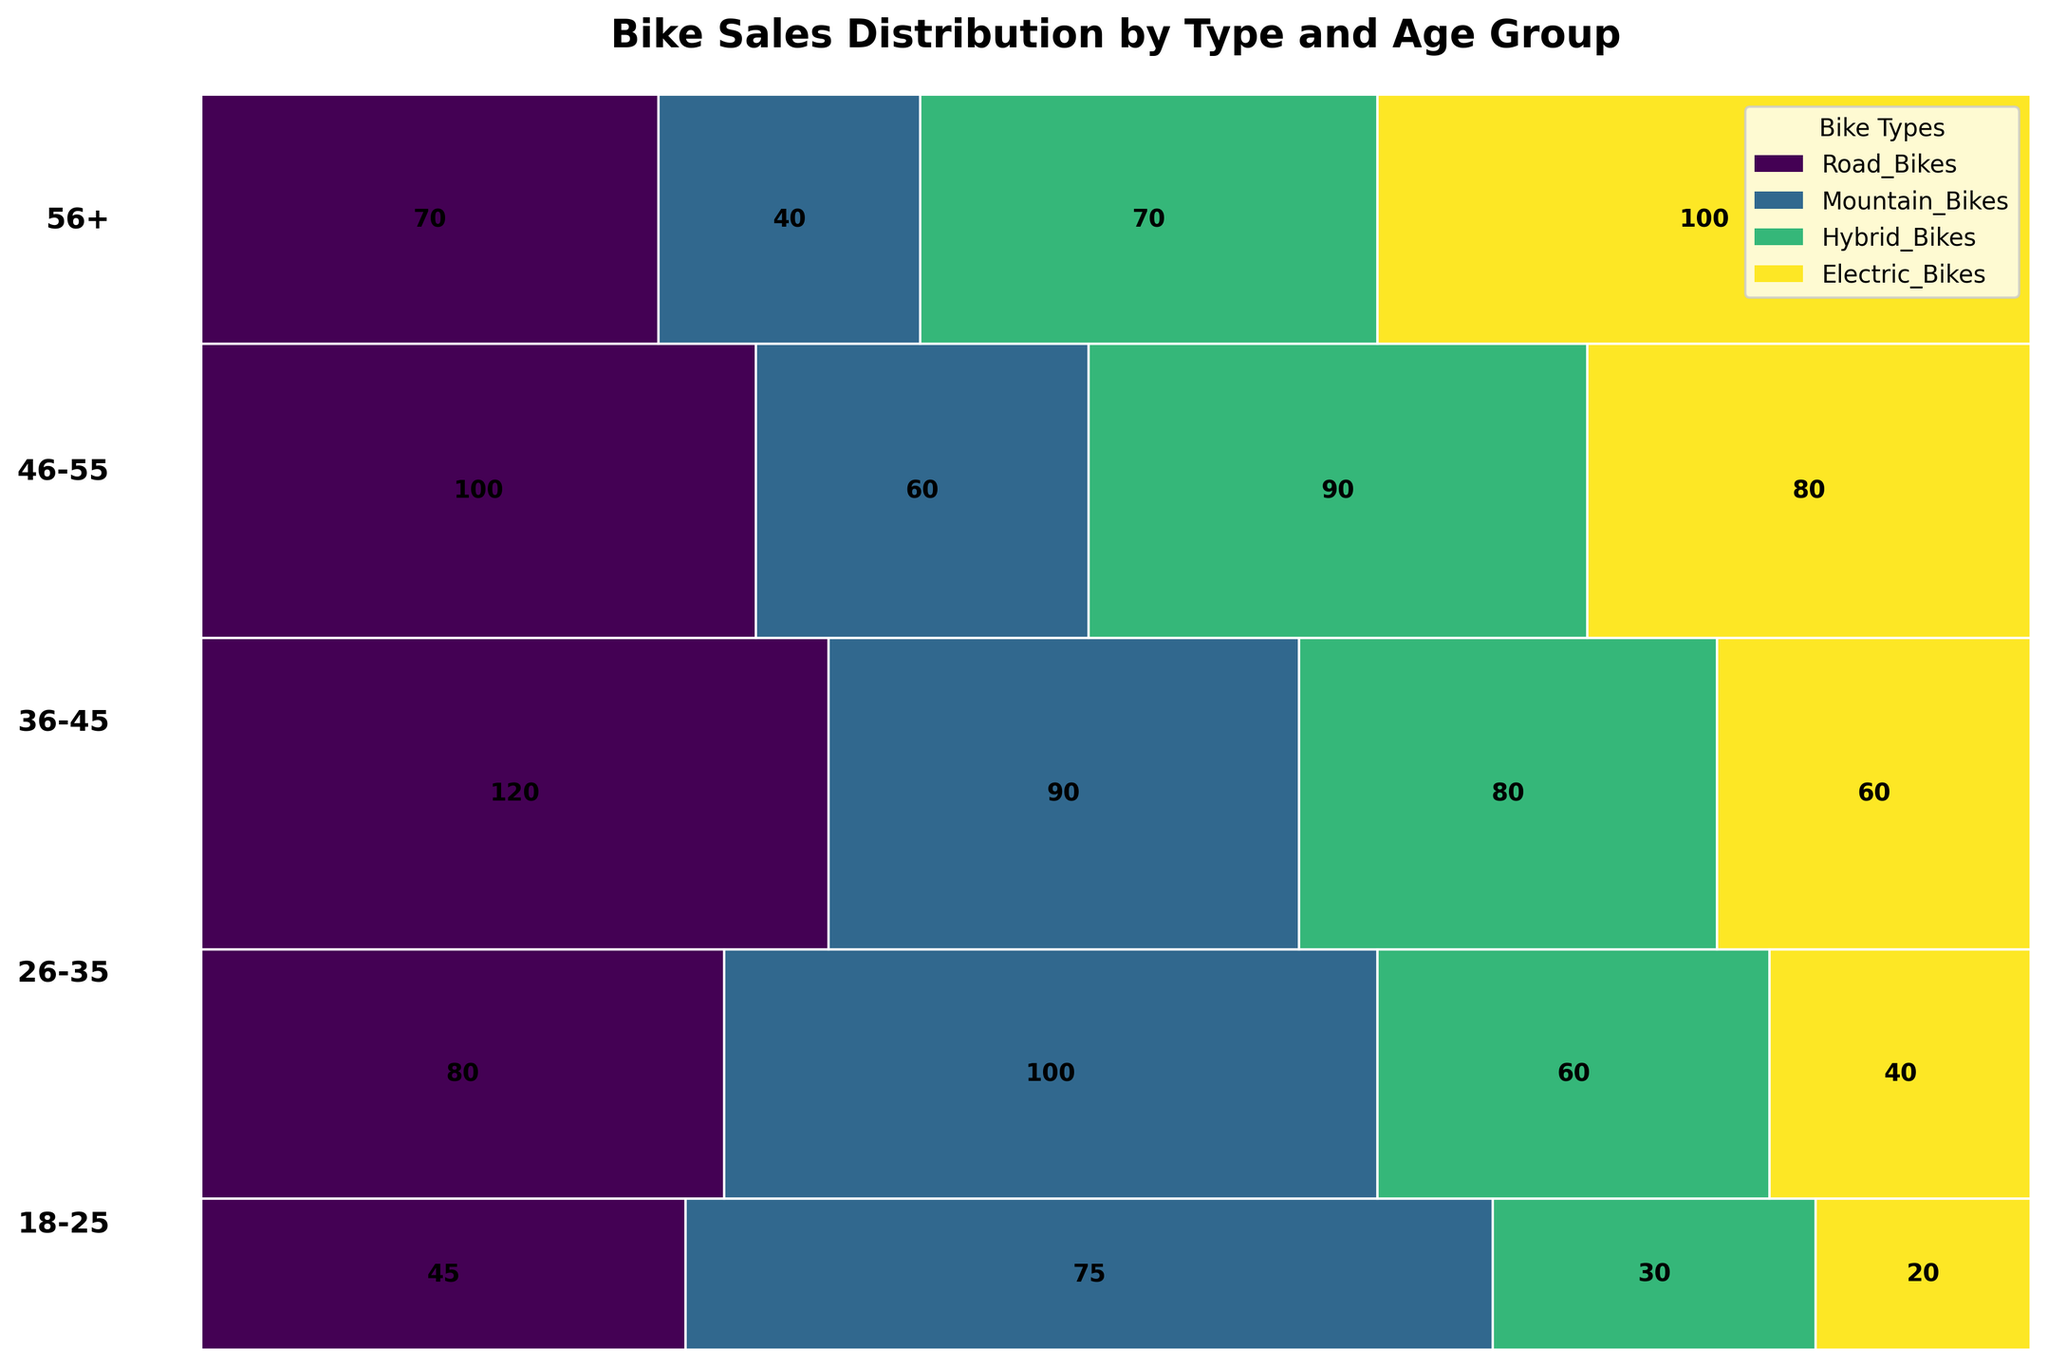What is the title of the figure? The title of the figure is displayed prominently at the top. Reading the text reveals the title.
Answer: Bike Sales Distribution by Type and Age Group Which age group has the highest number of Road Bikes sold? You need to check the tallest rectangle representing Road Bikes in each age group and compare their heights. The tallest rectangle for Road Bikes (green color) corresponds to the age group 36-45.
Answer: 36-45 In which age group are Electric Bikes most popular? Look for the thickest section of rectangles representing Electric Bikes (yellow color) across all age groups. The section is widest for the 56+ age group.
Answer: 56+ Which bike type is least popular among the 18-25 age group? Compare the widths of all four bike type rectangles for the 18-25 age group. The narrowest width indicates the least popular bike type. Electric Bikes (yellow) have the narrowest width.
Answer: Electric Bikes How many Hybrid Bikes are sold to the 26-35 age group? Find the rectangle representing Hybrid Bikes (blue color) for the 26-35 age group and read the number inside. The number displayed inside the rectangle is 60.
Answer: 60 Which age group has the smallest total bike sales, and what is that number? Compare the heights of the age groups' total bars to determine the smallest. The 18-25 age group has the smallest total height, and the number inside the total height rectangle is 170 (45+75+30+20).
Answer: 18-25, 170 How do the sales of Mountain Bikes compare between the 46-55 and 56+ age groups? Compare the widths of the Mountain Bikes' (orange color) rectangles for both age groups. The width for the 46-55 age group is larger than for the 56+ age group showing higher sales (60 vs. 40).
Answer: 46-55 > 56+ What is the combined total of Road and Mountain Bikes sold in the 36-45 age group? Add the numbers for Road Bikes and Mountain Bikes in the 36-45 age group. The numbers are 120 and 90, so the total is 120 + 90 = 210.
Answer: 210 Which bike type has the most consistent popularity across all age groups? Judging by evenly distributed widths across different age groups, Hybrid Bikes (blue color) appear to have a relatively even width, indicating consistent popularity.
Answer: Hybrid Bikes 